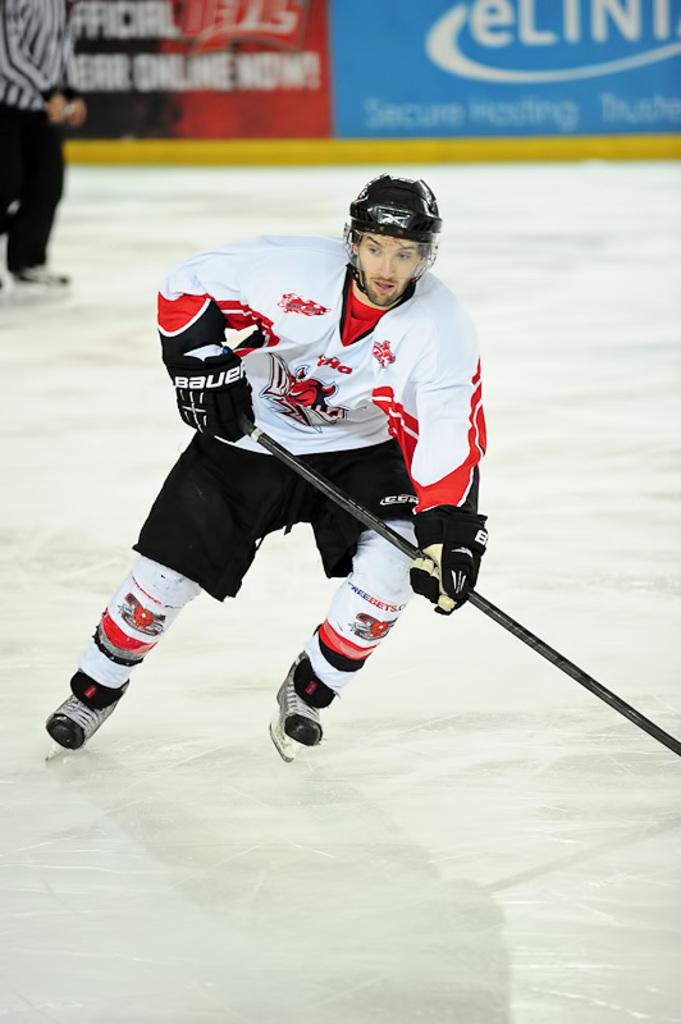What is the person in the image doing? There is a person skating in the image. What is the person holding while skating? The person is holding a stick. Can you describe the colors and design of the person's dress? The person is wearing a dress with white, red, and black colors. Is there anyone else visible in the image? Yes, there is another person visible in the background. What can be seen in the background besides the other person? There are colorful boards in the background. What type of plastic is being used to create a flame in the image? There is no plastic or flame present in the image. How is the person in the image connected to the colorful boards in the background? The person in the image is not connected to the colorful boards in the background; they are simply skating in front of them. 